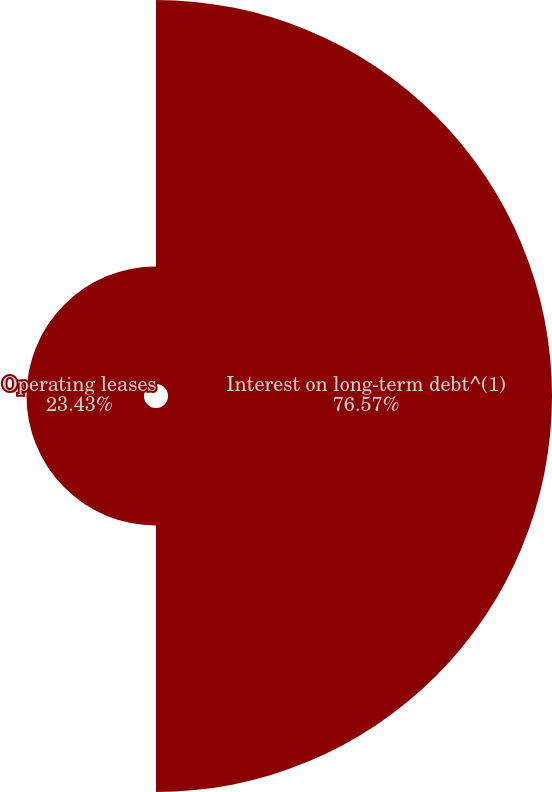Convert chart. <chart><loc_0><loc_0><loc_500><loc_500><pie_chart><fcel>Interest on long-term debt^(1)<fcel>Operating leases<nl><fcel>76.57%<fcel>23.43%<nl></chart> 